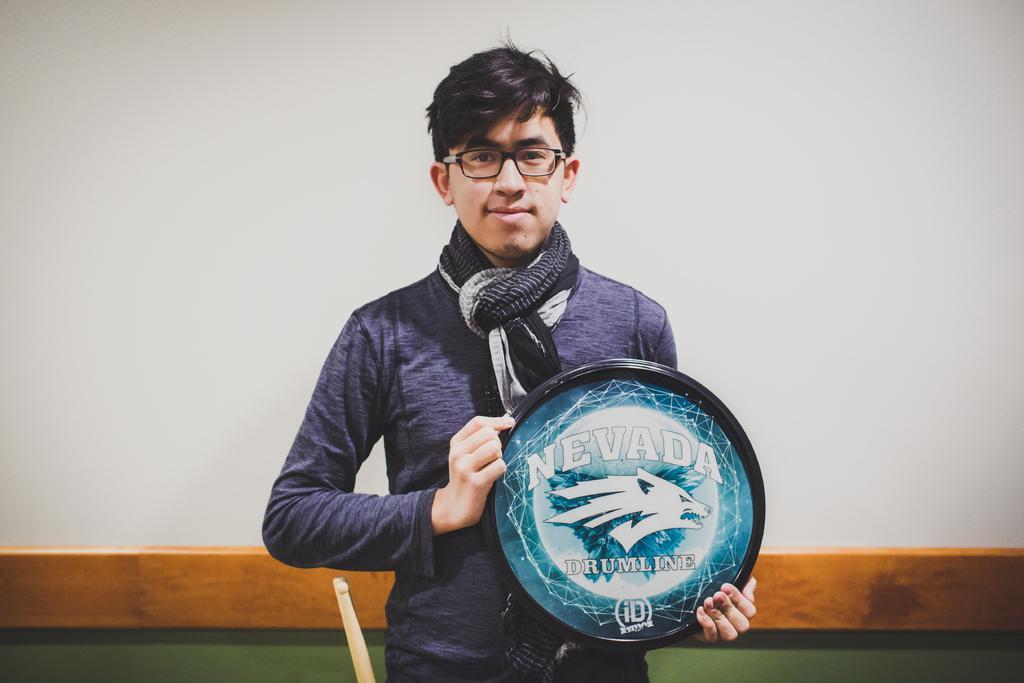How would you summarize this image in a sentence or two? In this image we can see a man standing and holding a memento in his hands. 